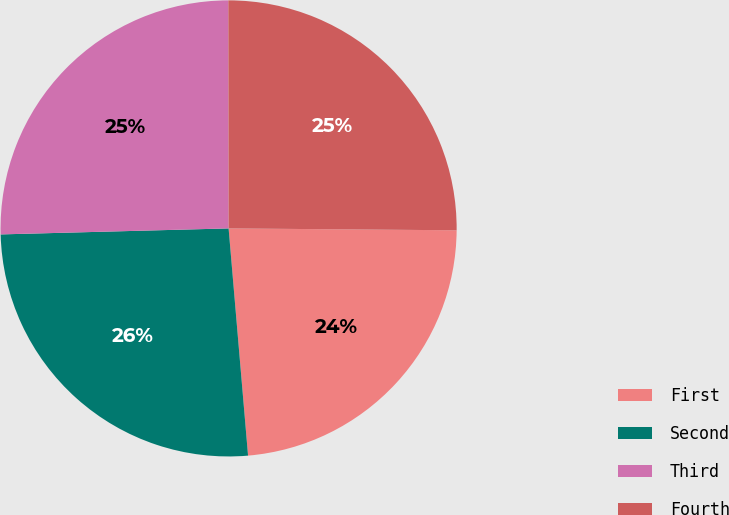<chart> <loc_0><loc_0><loc_500><loc_500><pie_chart><fcel>First<fcel>Second<fcel>Third<fcel>Fourth<nl><fcel>23.51%<fcel>25.94%<fcel>25.4%<fcel>25.15%<nl></chart> 